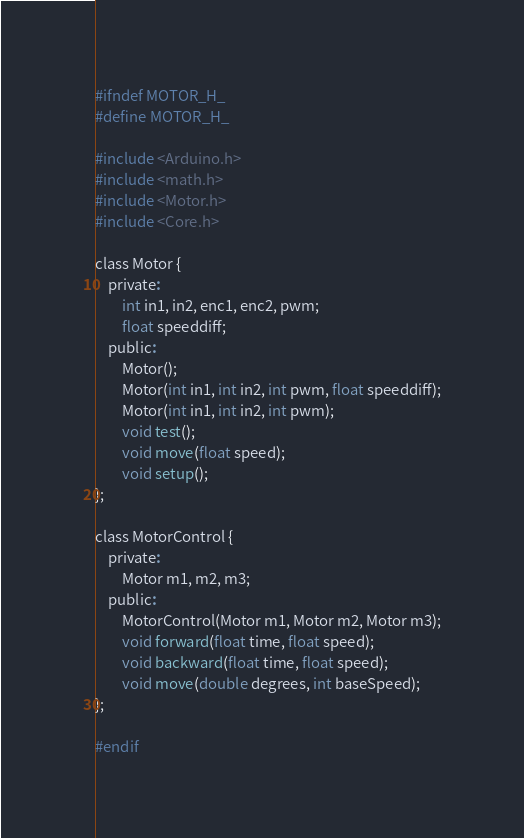<code> <loc_0><loc_0><loc_500><loc_500><_C_>#ifndef MOTOR_H_
#define MOTOR_H_

#include <Arduino.h>
#include <math.h>
#include <Motor.h>
#include <Core.h>

class Motor {
    private:
        int in1, in2, enc1, enc2, pwm;
        float speeddiff;
    public:
        Motor();
        Motor(int in1, int in2, int pwm, float speeddiff);
        Motor(int in1, int in2, int pwm);
        void test(); 
        void move(float speed);
        void setup();
};

class MotorControl {
    private:
        Motor m1, m2, m3;
    public:
        MotorControl(Motor m1, Motor m2, Motor m3);
        void forward(float time, float speed); 
        void backward(float time, float speed);
        void move(double degrees, int baseSpeed);
};

#endif</code> 